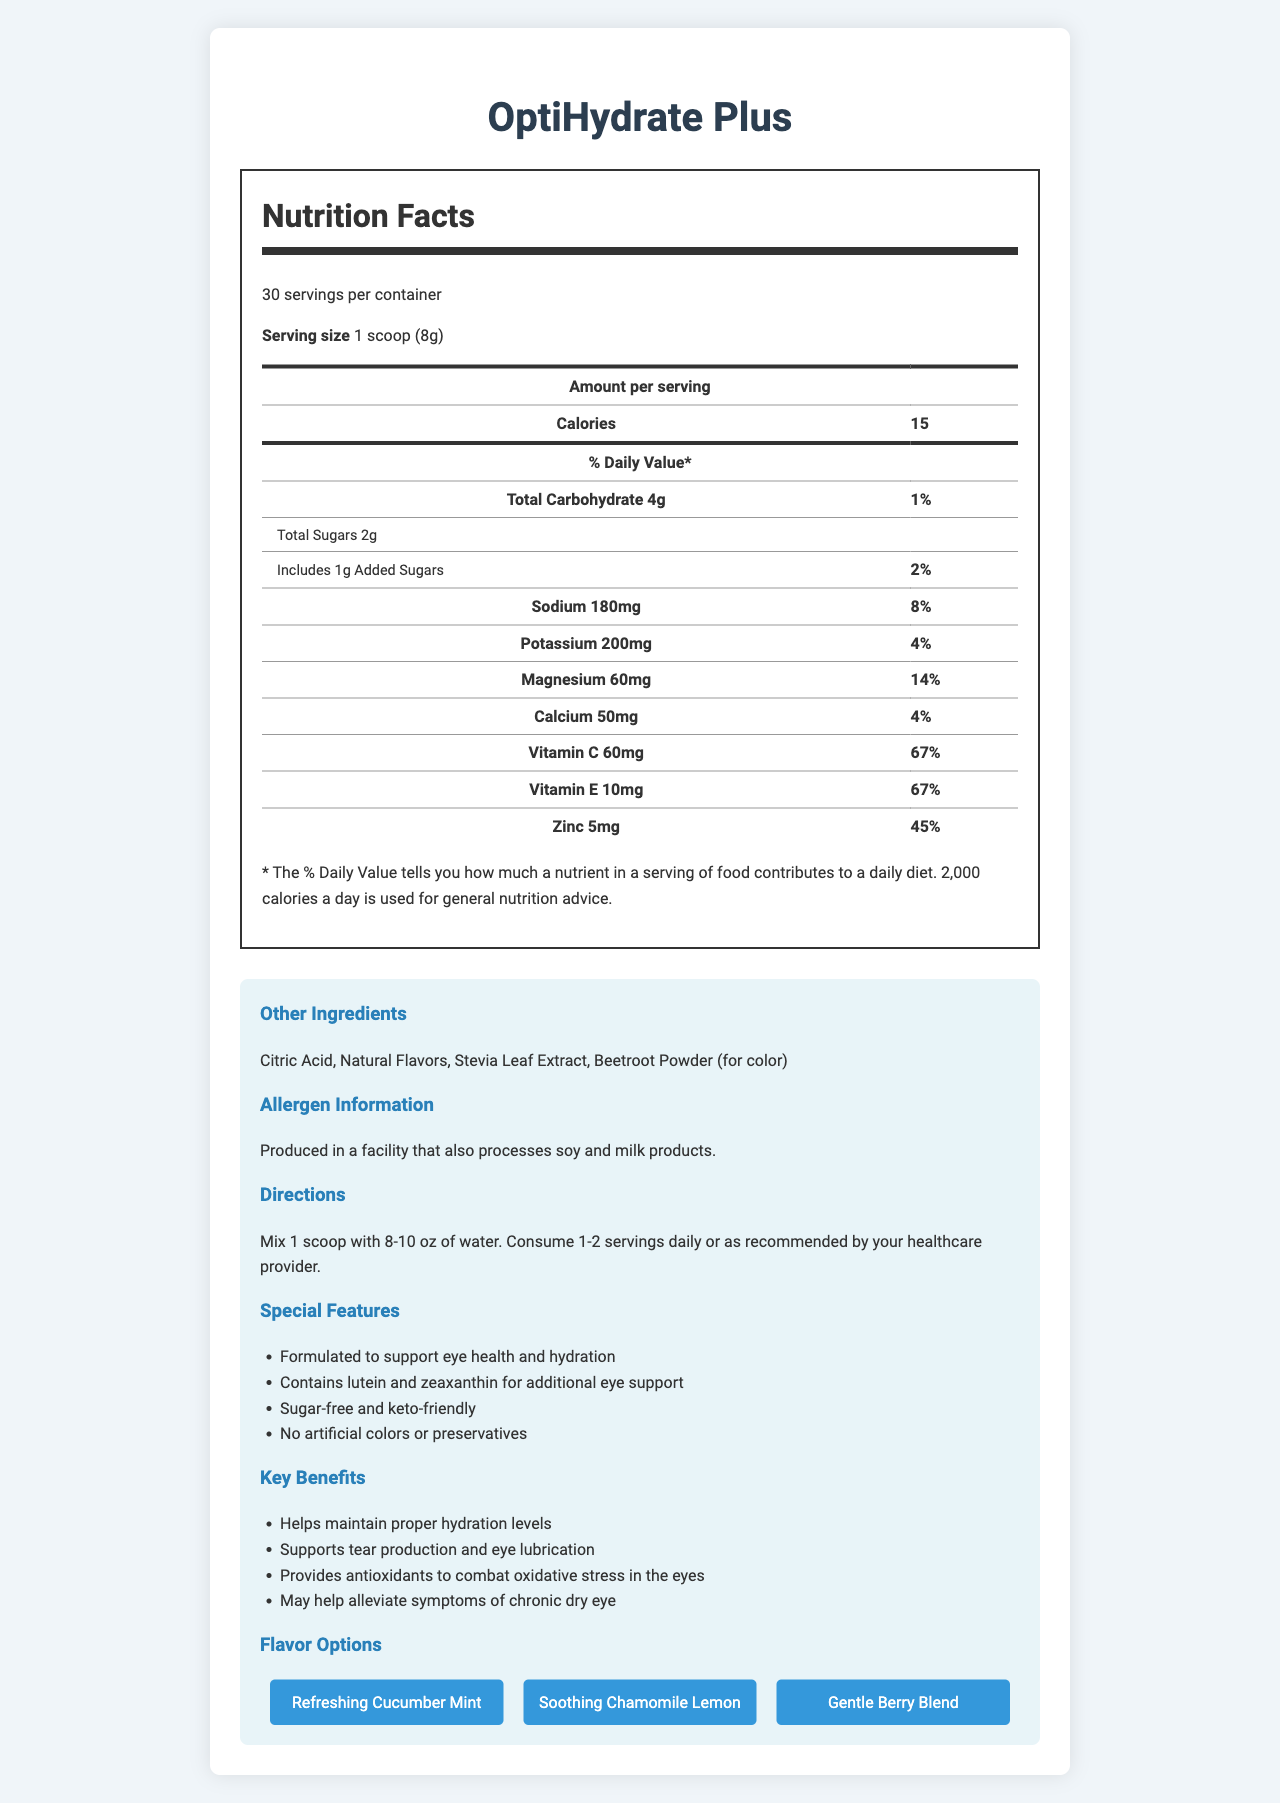what is the serving size of OptiHydrate Plus? The serving size is clearly mentioned as "1 scoop (8g)" under the "Nutrition Facts" section.
Answer: 1 scoop (8g) how many calories are there in one serving of OptiHydrate Plus? The "Amount per serving" section lists the calories as 15.
Answer: 15 how much sugar does one serving of the powder mix contain? The "Total Sugars" under the carbohydrate section indicates 2g of sugar per serving.
Answer: 2g how many milligrams of potassium are in one serving? The "Potassium" section lists 200mg per serving.
Answer: 200mg what percentage of daily value does the magnesium content make up? The "Magnesium" section lists the daily value percentage as 14%.
Answer: 14% which vitamins are present in the powder mix? The vitamins listed are Vitamin C (60mg, 67% daily value) and Vitamin E (10mg, 67% daily value).
Answer: Vitamin C and Vitamin E what is the allergen information related to this product? The allergen information is mentioned clearly in the "Allergen Information" section.
Answer: Produced in a facility that also processes soy and milk products. what are the key benefits of using OptiHydrate Plus? The key benefits are listed under the "Key Benefits" section.
Answer: Helps maintain proper hydration levels, supports tear production and eye lubrication, provides antioxidants to combat oxidative stress in the eyes, may help alleviate symptoms of chronic dry eye. which flavors are available for OptiHydrate Plus? The available flavors are mentioned in the "Flavor Options" section.
Answer: Refreshing Cucumber Mint, Soothing Chamomile Lemon, Gentle Berry Blend what is the recommended number of servings per day? The recommended serving information is provided in the "Directions" section.
Answer: 1-2 servings daily or as recommended by your healthcare provider how many servings are there per container? A. 15 B. 20 C. 25 D. 30 The document mentions that there are 30 servings per container.
Answer: D which of the following is NOT a special feature of OptiHydrate Plus? A. Contains artificial colors B. Sugar-free and keto-friendly C. Formulated to support eye health and hydration D. No artificial colors or preservatives The special features list indicates that OptiHydrate Plus contains no artificial colors but does support eye health, is sugar-free and keto-friendly, and contains no preservatives.
Answer: A is the product sugar-free? The product includes 2g of total sugars per serving as indicated in the nutrition facts.
Answer: No summarize the main purpose of OptiHydrate Plus. OptiHydrate Plus aims to support eye health through hydration and essential nutrients. It is designed to help people with chronic dry eye, providing essential electrolytes and antioxidants to combat oxidative stress.
Answer: OptiHydrate Plus is a hydrating electrolyte powder mix with added antioxidants that supports eye health by aiding tear production and lubrication, and helps alleviate symptoms of chronic dry eye. It also helps maintain hydration levels and provides antioxidants to combat oxidative stress in the eyes. The product contains essential nutrients such as Vitamin C, Vitamin E, and Zinc and comes in various flavors. does the document mention how the product helps with dry eyes? The key benefits section specifically states that the product supports tear production and eye lubrication and may help alleviate symptoms of chronic dry eye.
Answer: Yes what is the price of OptiHydrate Plus? The document does not provide any information related to the price of the product.
Answer: Not enough information 